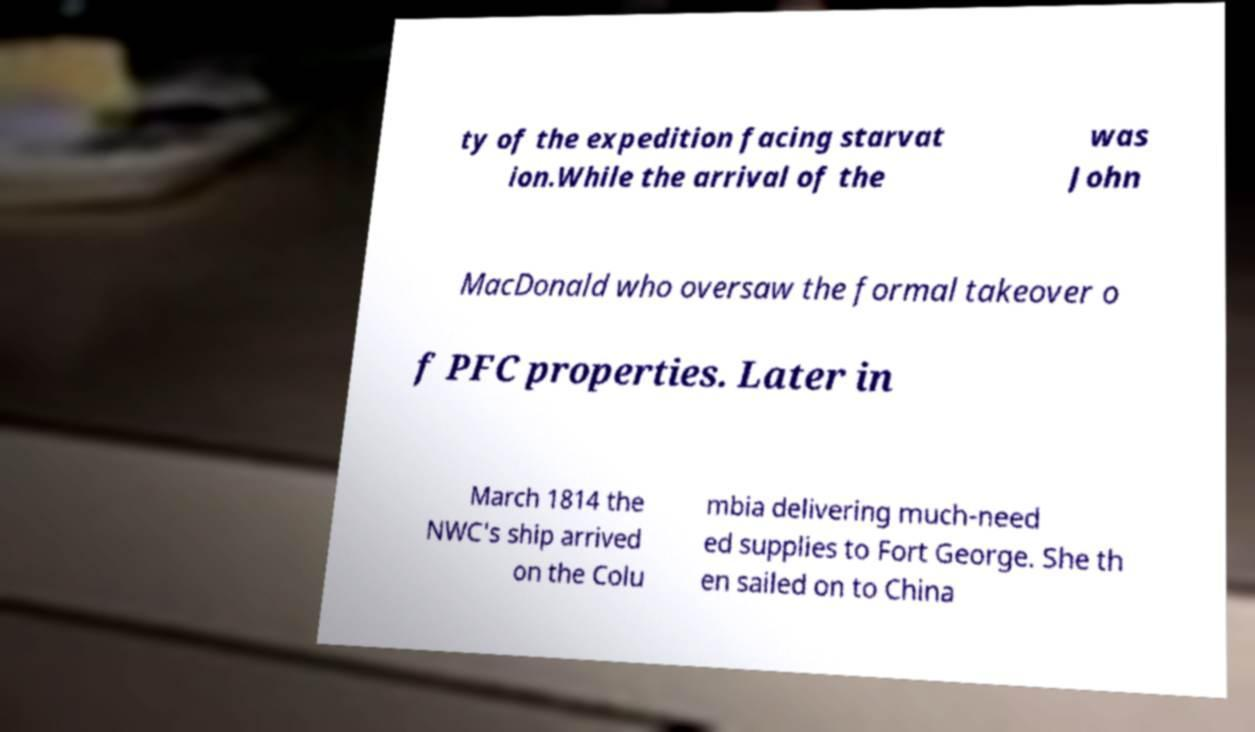Can you accurately transcribe the text from the provided image for me? ty of the expedition facing starvat ion.While the arrival of the was John MacDonald who oversaw the formal takeover o f PFC properties. Later in March 1814 the NWC's ship arrived on the Colu mbia delivering much-need ed supplies to Fort George. She th en sailed on to China 